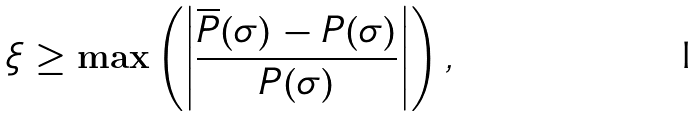Convert formula to latex. <formula><loc_0><loc_0><loc_500><loc_500>\xi \geq \max \left ( \left | \frac { \overline { P } ( \sigma ) - P ( \sigma ) } { P ( \sigma ) } \right | \right ) ,</formula> 